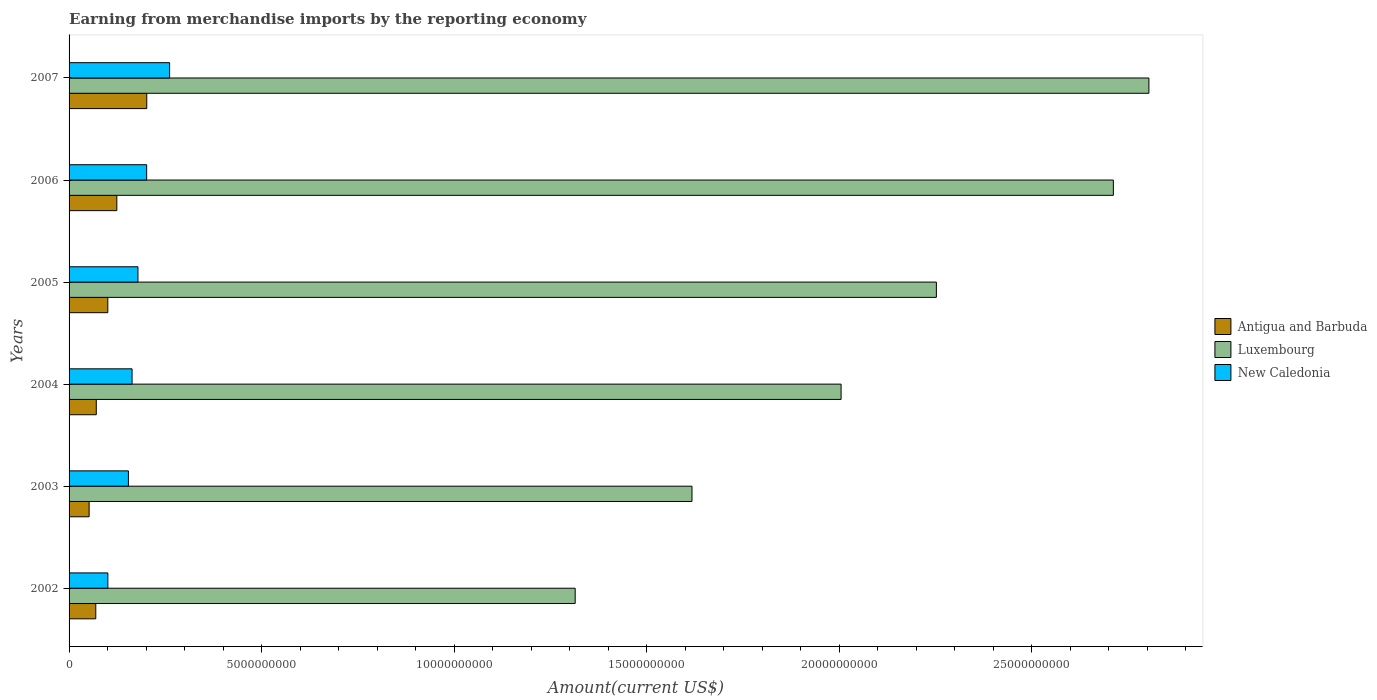How many different coloured bars are there?
Provide a succinct answer. 3. How many groups of bars are there?
Ensure brevity in your answer.  6. Are the number of bars per tick equal to the number of legend labels?
Keep it short and to the point. Yes. Are the number of bars on each tick of the Y-axis equal?
Make the answer very short. Yes. In how many cases, is the number of bars for a given year not equal to the number of legend labels?
Give a very brief answer. 0. What is the amount earned from merchandise imports in Luxembourg in 2007?
Provide a short and direct response. 2.80e+1. Across all years, what is the maximum amount earned from merchandise imports in Luxembourg?
Offer a very short reply. 2.80e+1. Across all years, what is the minimum amount earned from merchandise imports in Luxembourg?
Provide a succinct answer. 1.31e+1. In which year was the amount earned from merchandise imports in Luxembourg maximum?
Give a very brief answer. 2007. In which year was the amount earned from merchandise imports in Antigua and Barbuda minimum?
Provide a succinct answer. 2003. What is the total amount earned from merchandise imports in New Caledonia in the graph?
Make the answer very short. 1.06e+1. What is the difference between the amount earned from merchandise imports in New Caledonia in 2004 and that in 2007?
Offer a terse response. -9.75e+08. What is the difference between the amount earned from merchandise imports in New Caledonia in 2006 and the amount earned from merchandise imports in Antigua and Barbuda in 2003?
Your answer should be very brief. 1.49e+09. What is the average amount earned from merchandise imports in Antigua and Barbuda per year?
Provide a succinct answer. 1.03e+09. In the year 2002, what is the difference between the amount earned from merchandise imports in New Caledonia and amount earned from merchandise imports in Luxembourg?
Offer a very short reply. -1.21e+1. In how many years, is the amount earned from merchandise imports in New Caledonia greater than 28000000000 US$?
Your answer should be very brief. 0. What is the ratio of the amount earned from merchandise imports in New Caledonia in 2002 to that in 2005?
Your answer should be compact. 0.56. Is the amount earned from merchandise imports in New Caledonia in 2004 less than that in 2005?
Provide a short and direct response. Yes. What is the difference between the highest and the second highest amount earned from merchandise imports in Antigua and Barbuda?
Your answer should be very brief. 7.78e+08. What is the difference between the highest and the lowest amount earned from merchandise imports in Antigua and Barbuda?
Give a very brief answer. 1.50e+09. In how many years, is the amount earned from merchandise imports in Antigua and Barbuda greater than the average amount earned from merchandise imports in Antigua and Barbuda taken over all years?
Make the answer very short. 2. Is the sum of the amount earned from merchandise imports in Antigua and Barbuda in 2002 and 2006 greater than the maximum amount earned from merchandise imports in Luxembourg across all years?
Your answer should be compact. No. What does the 2nd bar from the top in 2003 represents?
Ensure brevity in your answer.  Luxembourg. What does the 2nd bar from the bottom in 2002 represents?
Make the answer very short. Luxembourg. Is it the case that in every year, the sum of the amount earned from merchandise imports in Luxembourg and amount earned from merchandise imports in New Caledonia is greater than the amount earned from merchandise imports in Antigua and Barbuda?
Provide a succinct answer. Yes. How many bars are there?
Provide a short and direct response. 18. Are all the bars in the graph horizontal?
Give a very brief answer. Yes. How many years are there in the graph?
Offer a very short reply. 6. What is the difference between two consecutive major ticks on the X-axis?
Provide a succinct answer. 5.00e+09. Does the graph contain any zero values?
Ensure brevity in your answer.  No. Does the graph contain grids?
Your answer should be compact. No. How many legend labels are there?
Give a very brief answer. 3. How are the legend labels stacked?
Your answer should be compact. Vertical. What is the title of the graph?
Your response must be concise. Earning from merchandise imports by the reporting economy. What is the label or title of the X-axis?
Provide a short and direct response. Amount(current US$). What is the Amount(current US$) of Antigua and Barbuda in 2002?
Provide a short and direct response. 6.94e+08. What is the Amount(current US$) of Luxembourg in 2002?
Your answer should be compact. 1.31e+1. What is the Amount(current US$) in New Caledonia in 2002?
Your response must be concise. 1.01e+09. What is the Amount(current US$) of Antigua and Barbuda in 2003?
Provide a succinct answer. 5.21e+08. What is the Amount(current US$) of Luxembourg in 2003?
Ensure brevity in your answer.  1.62e+1. What is the Amount(current US$) in New Caledonia in 2003?
Provide a short and direct response. 1.54e+09. What is the Amount(current US$) of Antigua and Barbuda in 2004?
Offer a terse response. 7.07e+08. What is the Amount(current US$) in Luxembourg in 2004?
Give a very brief answer. 2.01e+1. What is the Amount(current US$) in New Caledonia in 2004?
Provide a succinct answer. 1.64e+09. What is the Amount(current US$) of Antigua and Barbuda in 2005?
Your response must be concise. 1.01e+09. What is the Amount(current US$) in Luxembourg in 2005?
Provide a succinct answer. 2.25e+1. What is the Amount(current US$) in New Caledonia in 2005?
Your answer should be compact. 1.79e+09. What is the Amount(current US$) of Antigua and Barbuda in 2006?
Your response must be concise. 1.24e+09. What is the Amount(current US$) in Luxembourg in 2006?
Your response must be concise. 2.71e+1. What is the Amount(current US$) in New Caledonia in 2006?
Ensure brevity in your answer.  2.02e+09. What is the Amount(current US$) of Antigua and Barbuda in 2007?
Offer a terse response. 2.02e+09. What is the Amount(current US$) of Luxembourg in 2007?
Ensure brevity in your answer.  2.80e+1. What is the Amount(current US$) of New Caledonia in 2007?
Give a very brief answer. 2.61e+09. Across all years, what is the maximum Amount(current US$) of Antigua and Barbuda?
Keep it short and to the point. 2.02e+09. Across all years, what is the maximum Amount(current US$) in Luxembourg?
Provide a succinct answer. 2.80e+1. Across all years, what is the maximum Amount(current US$) of New Caledonia?
Give a very brief answer. 2.61e+09. Across all years, what is the minimum Amount(current US$) in Antigua and Barbuda?
Provide a short and direct response. 5.21e+08. Across all years, what is the minimum Amount(current US$) in Luxembourg?
Offer a very short reply. 1.31e+1. Across all years, what is the minimum Amount(current US$) of New Caledonia?
Make the answer very short. 1.01e+09. What is the total Amount(current US$) in Antigua and Barbuda in the graph?
Give a very brief answer. 6.19e+09. What is the total Amount(current US$) in Luxembourg in the graph?
Provide a succinct answer. 1.27e+11. What is the total Amount(current US$) of New Caledonia in the graph?
Make the answer very short. 1.06e+1. What is the difference between the Amount(current US$) of Antigua and Barbuda in 2002 and that in 2003?
Offer a very short reply. 1.73e+08. What is the difference between the Amount(current US$) in Luxembourg in 2002 and that in 2003?
Provide a short and direct response. -3.03e+09. What is the difference between the Amount(current US$) of New Caledonia in 2002 and that in 2003?
Ensure brevity in your answer.  -5.34e+08. What is the difference between the Amount(current US$) of Antigua and Barbuda in 2002 and that in 2004?
Offer a terse response. -1.32e+07. What is the difference between the Amount(current US$) in Luxembourg in 2002 and that in 2004?
Provide a succinct answer. -6.91e+09. What is the difference between the Amount(current US$) in New Caledonia in 2002 and that in 2004?
Your response must be concise. -6.29e+08. What is the difference between the Amount(current US$) of Antigua and Barbuda in 2002 and that in 2005?
Give a very brief answer. -3.13e+08. What is the difference between the Amount(current US$) in Luxembourg in 2002 and that in 2005?
Ensure brevity in your answer.  -9.38e+09. What is the difference between the Amount(current US$) of New Caledonia in 2002 and that in 2005?
Your answer should be very brief. -7.82e+08. What is the difference between the Amount(current US$) of Antigua and Barbuda in 2002 and that in 2006?
Your response must be concise. -5.47e+08. What is the difference between the Amount(current US$) of Luxembourg in 2002 and that in 2006?
Your answer should be compact. -1.40e+1. What is the difference between the Amount(current US$) in New Caledonia in 2002 and that in 2006?
Give a very brief answer. -1.01e+09. What is the difference between the Amount(current US$) in Antigua and Barbuda in 2002 and that in 2007?
Your answer should be compact. -1.32e+09. What is the difference between the Amount(current US$) in Luxembourg in 2002 and that in 2007?
Offer a terse response. -1.49e+1. What is the difference between the Amount(current US$) of New Caledonia in 2002 and that in 2007?
Ensure brevity in your answer.  -1.60e+09. What is the difference between the Amount(current US$) of Antigua and Barbuda in 2003 and that in 2004?
Your response must be concise. -1.86e+08. What is the difference between the Amount(current US$) of Luxembourg in 2003 and that in 2004?
Your response must be concise. -3.87e+09. What is the difference between the Amount(current US$) in New Caledonia in 2003 and that in 2004?
Your response must be concise. -9.53e+07. What is the difference between the Amount(current US$) of Antigua and Barbuda in 2003 and that in 2005?
Provide a short and direct response. -4.86e+08. What is the difference between the Amount(current US$) of Luxembourg in 2003 and that in 2005?
Provide a short and direct response. -6.35e+09. What is the difference between the Amount(current US$) in New Caledonia in 2003 and that in 2005?
Provide a succinct answer. -2.48e+08. What is the difference between the Amount(current US$) in Antigua and Barbuda in 2003 and that in 2006?
Make the answer very short. -7.20e+08. What is the difference between the Amount(current US$) of Luxembourg in 2003 and that in 2006?
Offer a terse response. -1.09e+1. What is the difference between the Amount(current US$) of New Caledonia in 2003 and that in 2006?
Your response must be concise. -4.74e+08. What is the difference between the Amount(current US$) of Antigua and Barbuda in 2003 and that in 2007?
Your answer should be compact. -1.50e+09. What is the difference between the Amount(current US$) of Luxembourg in 2003 and that in 2007?
Provide a short and direct response. -1.19e+1. What is the difference between the Amount(current US$) in New Caledonia in 2003 and that in 2007?
Ensure brevity in your answer.  -1.07e+09. What is the difference between the Amount(current US$) in Antigua and Barbuda in 2004 and that in 2005?
Provide a short and direct response. -3.00e+08. What is the difference between the Amount(current US$) of Luxembourg in 2004 and that in 2005?
Your answer should be compact. -2.47e+09. What is the difference between the Amount(current US$) of New Caledonia in 2004 and that in 2005?
Offer a very short reply. -1.53e+08. What is the difference between the Amount(current US$) of Antigua and Barbuda in 2004 and that in 2006?
Offer a very short reply. -5.33e+08. What is the difference between the Amount(current US$) of Luxembourg in 2004 and that in 2006?
Provide a short and direct response. -7.07e+09. What is the difference between the Amount(current US$) in New Caledonia in 2004 and that in 2006?
Your answer should be compact. -3.79e+08. What is the difference between the Amount(current US$) in Antigua and Barbuda in 2004 and that in 2007?
Offer a terse response. -1.31e+09. What is the difference between the Amount(current US$) in Luxembourg in 2004 and that in 2007?
Offer a very short reply. -7.99e+09. What is the difference between the Amount(current US$) in New Caledonia in 2004 and that in 2007?
Keep it short and to the point. -9.75e+08. What is the difference between the Amount(current US$) in Antigua and Barbuda in 2005 and that in 2006?
Offer a very short reply. -2.34e+08. What is the difference between the Amount(current US$) in Luxembourg in 2005 and that in 2006?
Give a very brief answer. -4.60e+09. What is the difference between the Amount(current US$) in New Caledonia in 2005 and that in 2006?
Give a very brief answer. -2.26e+08. What is the difference between the Amount(current US$) of Antigua and Barbuda in 2005 and that in 2007?
Give a very brief answer. -1.01e+09. What is the difference between the Amount(current US$) of Luxembourg in 2005 and that in 2007?
Keep it short and to the point. -5.52e+09. What is the difference between the Amount(current US$) of New Caledonia in 2005 and that in 2007?
Make the answer very short. -8.22e+08. What is the difference between the Amount(current US$) of Antigua and Barbuda in 2006 and that in 2007?
Offer a terse response. -7.78e+08. What is the difference between the Amount(current US$) in Luxembourg in 2006 and that in 2007?
Offer a very short reply. -9.23e+08. What is the difference between the Amount(current US$) of New Caledonia in 2006 and that in 2007?
Make the answer very short. -5.96e+08. What is the difference between the Amount(current US$) of Antigua and Barbuda in 2002 and the Amount(current US$) of Luxembourg in 2003?
Ensure brevity in your answer.  -1.55e+1. What is the difference between the Amount(current US$) in Antigua and Barbuda in 2002 and the Amount(current US$) in New Caledonia in 2003?
Your answer should be compact. -8.47e+08. What is the difference between the Amount(current US$) of Luxembourg in 2002 and the Amount(current US$) of New Caledonia in 2003?
Your answer should be very brief. 1.16e+1. What is the difference between the Amount(current US$) in Antigua and Barbuda in 2002 and the Amount(current US$) in Luxembourg in 2004?
Your answer should be compact. -1.94e+1. What is the difference between the Amount(current US$) in Antigua and Barbuda in 2002 and the Amount(current US$) in New Caledonia in 2004?
Make the answer very short. -9.43e+08. What is the difference between the Amount(current US$) in Luxembourg in 2002 and the Amount(current US$) in New Caledonia in 2004?
Offer a terse response. 1.15e+1. What is the difference between the Amount(current US$) in Antigua and Barbuda in 2002 and the Amount(current US$) in Luxembourg in 2005?
Make the answer very short. -2.18e+1. What is the difference between the Amount(current US$) in Antigua and Barbuda in 2002 and the Amount(current US$) in New Caledonia in 2005?
Provide a succinct answer. -1.10e+09. What is the difference between the Amount(current US$) in Luxembourg in 2002 and the Amount(current US$) in New Caledonia in 2005?
Offer a terse response. 1.14e+1. What is the difference between the Amount(current US$) in Antigua and Barbuda in 2002 and the Amount(current US$) in Luxembourg in 2006?
Make the answer very short. -2.64e+1. What is the difference between the Amount(current US$) of Antigua and Barbuda in 2002 and the Amount(current US$) of New Caledonia in 2006?
Your answer should be very brief. -1.32e+09. What is the difference between the Amount(current US$) in Luxembourg in 2002 and the Amount(current US$) in New Caledonia in 2006?
Your answer should be very brief. 1.11e+1. What is the difference between the Amount(current US$) of Antigua and Barbuda in 2002 and the Amount(current US$) of Luxembourg in 2007?
Keep it short and to the point. -2.74e+1. What is the difference between the Amount(current US$) of Antigua and Barbuda in 2002 and the Amount(current US$) of New Caledonia in 2007?
Keep it short and to the point. -1.92e+09. What is the difference between the Amount(current US$) in Luxembourg in 2002 and the Amount(current US$) in New Caledonia in 2007?
Make the answer very short. 1.05e+1. What is the difference between the Amount(current US$) of Antigua and Barbuda in 2003 and the Amount(current US$) of Luxembourg in 2004?
Offer a very short reply. -1.95e+1. What is the difference between the Amount(current US$) of Antigua and Barbuda in 2003 and the Amount(current US$) of New Caledonia in 2004?
Offer a terse response. -1.12e+09. What is the difference between the Amount(current US$) of Luxembourg in 2003 and the Amount(current US$) of New Caledonia in 2004?
Give a very brief answer. 1.45e+1. What is the difference between the Amount(current US$) in Antigua and Barbuda in 2003 and the Amount(current US$) in Luxembourg in 2005?
Provide a short and direct response. -2.20e+1. What is the difference between the Amount(current US$) of Antigua and Barbuda in 2003 and the Amount(current US$) of New Caledonia in 2005?
Provide a short and direct response. -1.27e+09. What is the difference between the Amount(current US$) of Luxembourg in 2003 and the Amount(current US$) of New Caledonia in 2005?
Ensure brevity in your answer.  1.44e+1. What is the difference between the Amount(current US$) in Antigua and Barbuda in 2003 and the Amount(current US$) in Luxembourg in 2006?
Provide a succinct answer. -2.66e+1. What is the difference between the Amount(current US$) in Antigua and Barbuda in 2003 and the Amount(current US$) in New Caledonia in 2006?
Make the answer very short. -1.49e+09. What is the difference between the Amount(current US$) in Luxembourg in 2003 and the Amount(current US$) in New Caledonia in 2006?
Provide a short and direct response. 1.42e+1. What is the difference between the Amount(current US$) in Antigua and Barbuda in 2003 and the Amount(current US$) in Luxembourg in 2007?
Make the answer very short. -2.75e+1. What is the difference between the Amount(current US$) of Antigua and Barbuda in 2003 and the Amount(current US$) of New Caledonia in 2007?
Give a very brief answer. -2.09e+09. What is the difference between the Amount(current US$) in Luxembourg in 2003 and the Amount(current US$) in New Caledonia in 2007?
Your answer should be very brief. 1.36e+1. What is the difference between the Amount(current US$) of Antigua and Barbuda in 2004 and the Amount(current US$) of Luxembourg in 2005?
Ensure brevity in your answer.  -2.18e+1. What is the difference between the Amount(current US$) in Antigua and Barbuda in 2004 and the Amount(current US$) in New Caledonia in 2005?
Provide a short and direct response. -1.08e+09. What is the difference between the Amount(current US$) in Luxembourg in 2004 and the Amount(current US$) in New Caledonia in 2005?
Your response must be concise. 1.83e+1. What is the difference between the Amount(current US$) in Antigua and Barbuda in 2004 and the Amount(current US$) in Luxembourg in 2006?
Offer a terse response. -2.64e+1. What is the difference between the Amount(current US$) in Antigua and Barbuda in 2004 and the Amount(current US$) in New Caledonia in 2006?
Keep it short and to the point. -1.31e+09. What is the difference between the Amount(current US$) of Luxembourg in 2004 and the Amount(current US$) of New Caledonia in 2006?
Offer a terse response. 1.80e+1. What is the difference between the Amount(current US$) in Antigua and Barbuda in 2004 and the Amount(current US$) in Luxembourg in 2007?
Keep it short and to the point. -2.73e+1. What is the difference between the Amount(current US$) in Antigua and Barbuda in 2004 and the Amount(current US$) in New Caledonia in 2007?
Your answer should be very brief. -1.90e+09. What is the difference between the Amount(current US$) in Luxembourg in 2004 and the Amount(current US$) in New Caledonia in 2007?
Make the answer very short. 1.74e+1. What is the difference between the Amount(current US$) of Antigua and Barbuda in 2005 and the Amount(current US$) of Luxembourg in 2006?
Offer a terse response. -2.61e+1. What is the difference between the Amount(current US$) in Antigua and Barbuda in 2005 and the Amount(current US$) in New Caledonia in 2006?
Your response must be concise. -1.01e+09. What is the difference between the Amount(current US$) in Luxembourg in 2005 and the Amount(current US$) in New Caledonia in 2006?
Your answer should be compact. 2.05e+1. What is the difference between the Amount(current US$) in Antigua and Barbuda in 2005 and the Amount(current US$) in Luxembourg in 2007?
Provide a succinct answer. -2.70e+1. What is the difference between the Amount(current US$) of Antigua and Barbuda in 2005 and the Amount(current US$) of New Caledonia in 2007?
Your answer should be compact. -1.60e+09. What is the difference between the Amount(current US$) of Luxembourg in 2005 and the Amount(current US$) of New Caledonia in 2007?
Provide a succinct answer. 1.99e+1. What is the difference between the Amount(current US$) in Antigua and Barbuda in 2006 and the Amount(current US$) in Luxembourg in 2007?
Give a very brief answer. -2.68e+1. What is the difference between the Amount(current US$) of Antigua and Barbuda in 2006 and the Amount(current US$) of New Caledonia in 2007?
Your answer should be compact. -1.37e+09. What is the difference between the Amount(current US$) in Luxembourg in 2006 and the Amount(current US$) in New Caledonia in 2007?
Make the answer very short. 2.45e+1. What is the average Amount(current US$) of Antigua and Barbuda per year?
Your answer should be very brief. 1.03e+09. What is the average Amount(current US$) in Luxembourg per year?
Provide a succinct answer. 2.12e+1. What is the average Amount(current US$) of New Caledonia per year?
Your answer should be compact. 1.77e+09. In the year 2002, what is the difference between the Amount(current US$) of Antigua and Barbuda and Amount(current US$) of Luxembourg?
Your response must be concise. -1.25e+1. In the year 2002, what is the difference between the Amount(current US$) of Antigua and Barbuda and Amount(current US$) of New Caledonia?
Make the answer very short. -3.14e+08. In the year 2002, what is the difference between the Amount(current US$) in Luxembourg and Amount(current US$) in New Caledonia?
Offer a terse response. 1.21e+1. In the year 2003, what is the difference between the Amount(current US$) of Antigua and Barbuda and Amount(current US$) of Luxembourg?
Keep it short and to the point. -1.57e+1. In the year 2003, what is the difference between the Amount(current US$) in Antigua and Barbuda and Amount(current US$) in New Caledonia?
Make the answer very short. -1.02e+09. In the year 2003, what is the difference between the Amount(current US$) of Luxembourg and Amount(current US$) of New Caledonia?
Keep it short and to the point. 1.46e+1. In the year 2004, what is the difference between the Amount(current US$) in Antigua and Barbuda and Amount(current US$) in Luxembourg?
Give a very brief answer. -1.93e+1. In the year 2004, what is the difference between the Amount(current US$) of Antigua and Barbuda and Amount(current US$) of New Caledonia?
Give a very brief answer. -9.29e+08. In the year 2004, what is the difference between the Amount(current US$) of Luxembourg and Amount(current US$) of New Caledonia?
Your answer should be very brief. 1.84e+1. In the year 2005, what is the difference between the Amount(current US$) in Antigua and Barbuda and Amount(current US$) in Luxembourg?
Your answer should be compact. -2.15e+1. In the year 2005, what is the difference between the Amount(current US$) of Antigua and Barbuda and Amount(current US$) of New Caledonia?
Your answer should be very brief. -7.83e+08. In the year 2005, what is the difference between the Amount(current US$) of Luxembourg and Amount(current US$) of New Caledonia?
Offer a very short reply. 2.07e+1. In the year 2006, what is the difference between the Amount(current US$) in Antigua and Barbuda and Amount(current US$) in Luxembourg?
Offer a terse response. -2.59e+1. In the year 2006, what is the difference between the Amount(current US$) of Antigua and Barbuda and Amount(current US$) of New Caledonia?
Provide a succinct answer. -7.75e+08. In the year 2006, what is the difference between the Amount(current US$) of Luxembourg and Amount(current US$) of New Caledonia?
Offer a very short reply. 2.51e+1. In the year 2007, what is the difference between the Amount(current US$) of Antigua and Barbuda and Amount(current US$) of Luxembourg?
Offer a terse response. -2.60e+1. In the year 2007, what is the difference between the Amount(current US$) of Antigua and Barbuda and Amount(current US$) of New Caledonia?
Offer a very short reply. -5.93e+08. In the year 2007, what is the difference between the Amount(current US$) of Luxembourg and Amount(current US$) of New Caledonia?
Your response must be concise. 2.54e+1. What is the ratio of the Amount(current US$) in Antigua and Barbuda in 2002 to that in 2003?
Provide a succinct answer. 1.33. What is the ratio of the Amount(current US$) in Luxembourg in 2002 to that in 2003?
Provide a succinct answer. 0.81. What is the ratio of the Amount(current US$) in New Caledonia in 2002 to that in 2003?
Your response must be concise. 0.65. What is the ratio of the Amount(current US$) in Antigua and Barbuda in 2002 to that in 2004?
Keep it short and to the point. 0.98. What is the ratio of the Amount(current US$) of Luxembourg in 2002 to that in 2004?
Give a very brief answer. 0.66. What is the ratio of the Amount(current US$) in New Caledonia in 2002 to that in 2004?
Make the answer very short. 0.62. What is the ratio of the Amount(current US$) of Antigua and Barbuda in 2002 to that in 2005?
Your answer should be very brief. 0.69. What is the ratio of the Amount(current US$) of Luxembourg in 2002 to that in 2005?
Ensure brevity in your answer.  0.58. What is the ratio of the Amount(current US$) of New Caledonia in 2002 to that in 2005?
Ensure brevity in your answer.  0.56. What is the ratio of the Amount(current US$) in Antigua and Barbuda in 2002 to that in 2006?
Your response must be concise. 0.56. What is the ratio of the Amount(current US$) in Luxembourg in 2002 to that in 2006?
Provide a short and direct response. 0.48. What is the ratio of the Amount(current US$) in New Caledonia in 2002 to that in 2006?
Your answer should be compact. 0.5. What is the ratio of the Amount(current US$) in Antigua and Barbuda in 2002 to that in 2007?
Your answer should be very brief. 0.34. What is the ratio of the Amount(current US$) in Luxembourg in 2002 to that in 2007?
Ensure brevity in your answer.  0.47. What is the ratio of the Amount(current US$) of New Caledonia in 2002 to that in 2007?
Provide a short and direct response. 0.39. What is the ratio of the Amount(current US$) of Antigua and Barbuda in 2003 to that in 2004?
Provide a short and direct response. 0.74. What is the ratio of the Amount(current US$) of Luxembourg in 2003 to that in 2004?
Your answer should be very brief. 0.81. What is the ratio of the Amount(current US$) of New Caledonia in 2003 to that in 2004?
Offer a very short reply. 0.94. What is the ratio of the Amount(current US$) in Antigua and Barbuda in 2003 to that in 2005?
Offer a very short reply. 0.52. What is the ratio of the Amount(current US$) in Luxembourg in 2003 to that in 2005?
Make the answer very short. 0.72. What is the ratio of the Amount(current US$) in New Caledonia in 2003 to that in 2005?
Ensure brevity in your answer.  0.86. What is the ratio of the Amount(current US$) in Antigua and Barbuda in 2003 to that in 2006?
Make the answer very short. 0.42. What is the ratio of the Amount(current US$) of Luxembourg in 2003 to that in 2006?
Your answer should be compact. 0.6. What is the ratio of the Amount(current US$) of New Caledonia in 2003 to that in 2006?
Provide a succinct answer. 0.76. What is the ratio of the Amount(current US$) of Antigua and Barbuda in 2003 to that in 2007?
Provide a short and direct response. 0.26. What is the ratio of the Amount(current US$) of Luxembourg in 2003 to that in 2007?
Offer a terse response. 0.58. What is the ratio of the Amount(current US$) of New Caledonia in 2003 to that in 2007?
Keep it short and to the point. 0.59. What is the ratio of the Amount(current US$) in Antigua and Barbuda in 2004 to that in 2005?
Make the answer very short. 0.7. What is the ratio of the Amount(current US$) of Luxembourg in 2004 to that in 2005?
Ensure brevity in your answer.  0.89. What is the ratio of the Amount(current US$) of New Caledonia in 2004 to that in 2005?
Your answer should be compact. 0.91. What is the ratio of the Amount(current US$) of Antigua and Barbuda in 2004 to that in 2006?
Keep it short and to the point. 0.57. What is the ratio of the Amount(current US$) of Luxembourg in 2004 to that in 2006?
Provide a succinct answer. 0.74. What is the ratio of the Amount(current US$) in New Caledonia in 2004 to that in 2006?
Your response must be concise. 0.81. What is the ratio of the Amount(current US$) of Antigua and Barbuda in 2004 to that in 2007?
Keep it short and to the point. 0.35. What is the ratio of the Amount(current US$) of Luxembourg in 2004 to that in 2007?
Your answer should be very brief. 0.71. What is the ratio of the Amount(current US$) in New Caledonia in 2004 to that in 2007?
Offer a very short reply. 0.63. What is the ratio of the Amount(current US$) of Antigua and Barbuda in 2005 to that in 2006?
Make the answer very short. 0.81. What is the ratio of the Amount(current US$) in Luxembourg in 2005 to that in 2006?
Offer a very short reply. 0.83. What is the ratio of the Amount(current US$) in New Caledonia in 2005 to that in 2006?
Provide a short and direct response. 0.89. What is the ratio of the Amount(current US$) in Antigua and Barbuda in 2005 to that in 2007?
Offer a terse response. 0.5. What is the ratio of the Amount(current US$) of Luxembourg in 2005 to that in 2007?
Give a very brief answer. 0.8. What is the ratio of the Amount(current US$) in New Caledonia in 2005 to that in 2007?
Offer a terse response. 0.69. What is the ratio of the Amount(current US$) in Antigua and Barbuda in 2006 to that in 2007?
Offer a terse response. 0.61. What is the ratio of the Amount(current US$) of Luxembourg in 2006 to that in 2007?
Your answer should be very brief. 0.97. What is the ratio of the Amount(current US$) of New Caledonia in 2006 to that in 2007?
Provide a succinct answer. 0.77. What is the difference between the highest and the second highest Amount(current US$) of Antigua and Barbuda?
Offer a terse response. 7.78e+08. What is the difference between the highest and the second highest Amount(current US$) of Luxembourg?
Ensure brevity in your answer.  9.23e+08. What is the difference between the highest and the second highest Amount(current US$) in New Caledonia?
Your response must be concise. 5.96e+08. What is the difference between the highest and the lowest Amount(current US$) in Antigua and Barbuda?
Your response must be concise. 1.50e+09. What is the difference between the highest and the lowest Amount(current US$) of Luxembourg?
Ensure brevity in your answer.  1.49e+1. What is the difference between the highest and the lowest Amount(current US$) in New Caledonia?
Your response must be concise. 1.60e+09. 